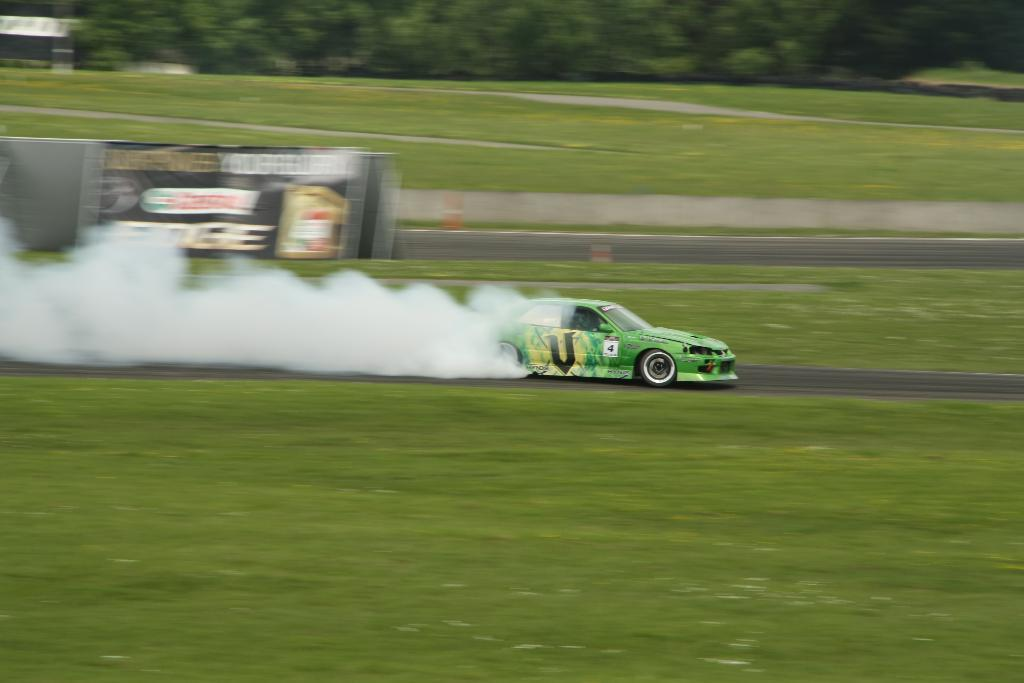What type of vehicle is in the image? There is a sports car in the image. Where is the sports car located? The sports car is on the road. What can be seen in the image besides the sports car? There is smoke visible in the image, as well as grass, a hoarding, and trees in the background. What color is the grass in the background? Green grass is visible in the background of the image. How many eyes can be seen on the sports car in the image? There are no eyes visible on the sports car in the image, as it is a vehicle and not a living being. 